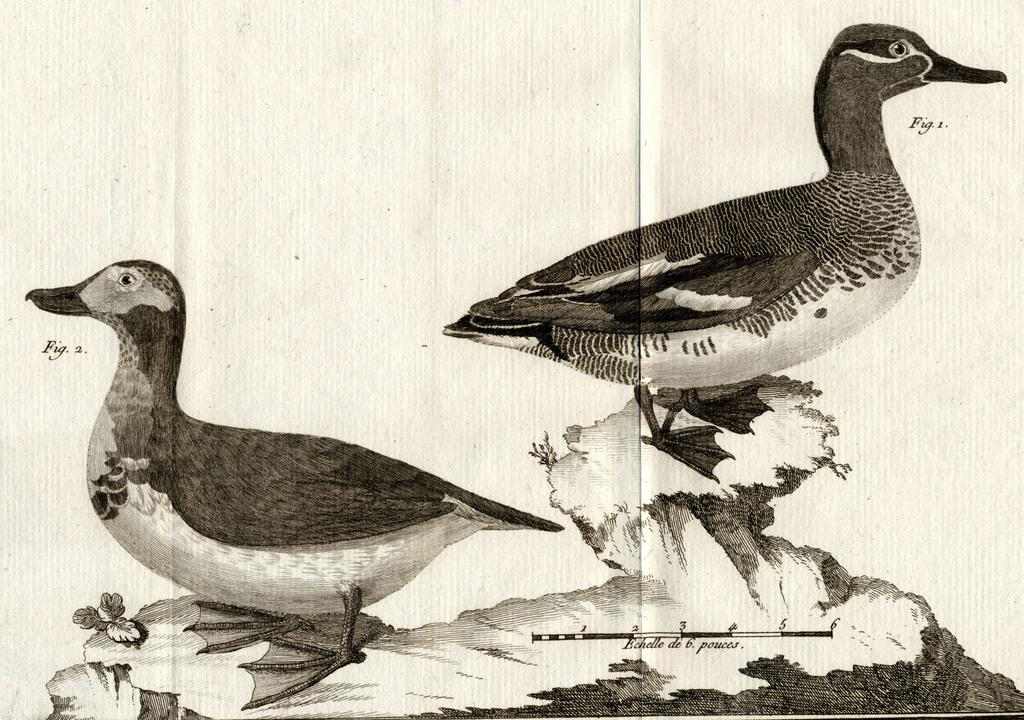What is depicted in the image? There is a sketch of two ducks in the image. What color is used for the sketch? The sketch is in black color. What material is the sketch drawn on? The sketch is drawn on paper. What type of flesh can be seen in the image? There is no flesh present in the image; it is a sketch of two ducks drawn on paper. 